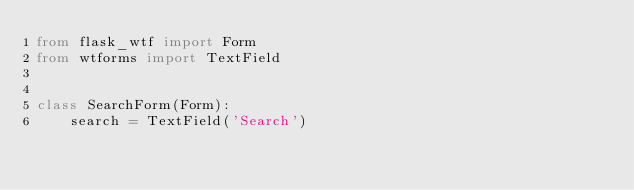Convert code to text. <code><loc_0><loc_0><loc_500><loc_500><_Python_>from flask_wtf import Form
from wtforms import TextField


class SearchForm(Form):
	search = TextField('Search')</code> 